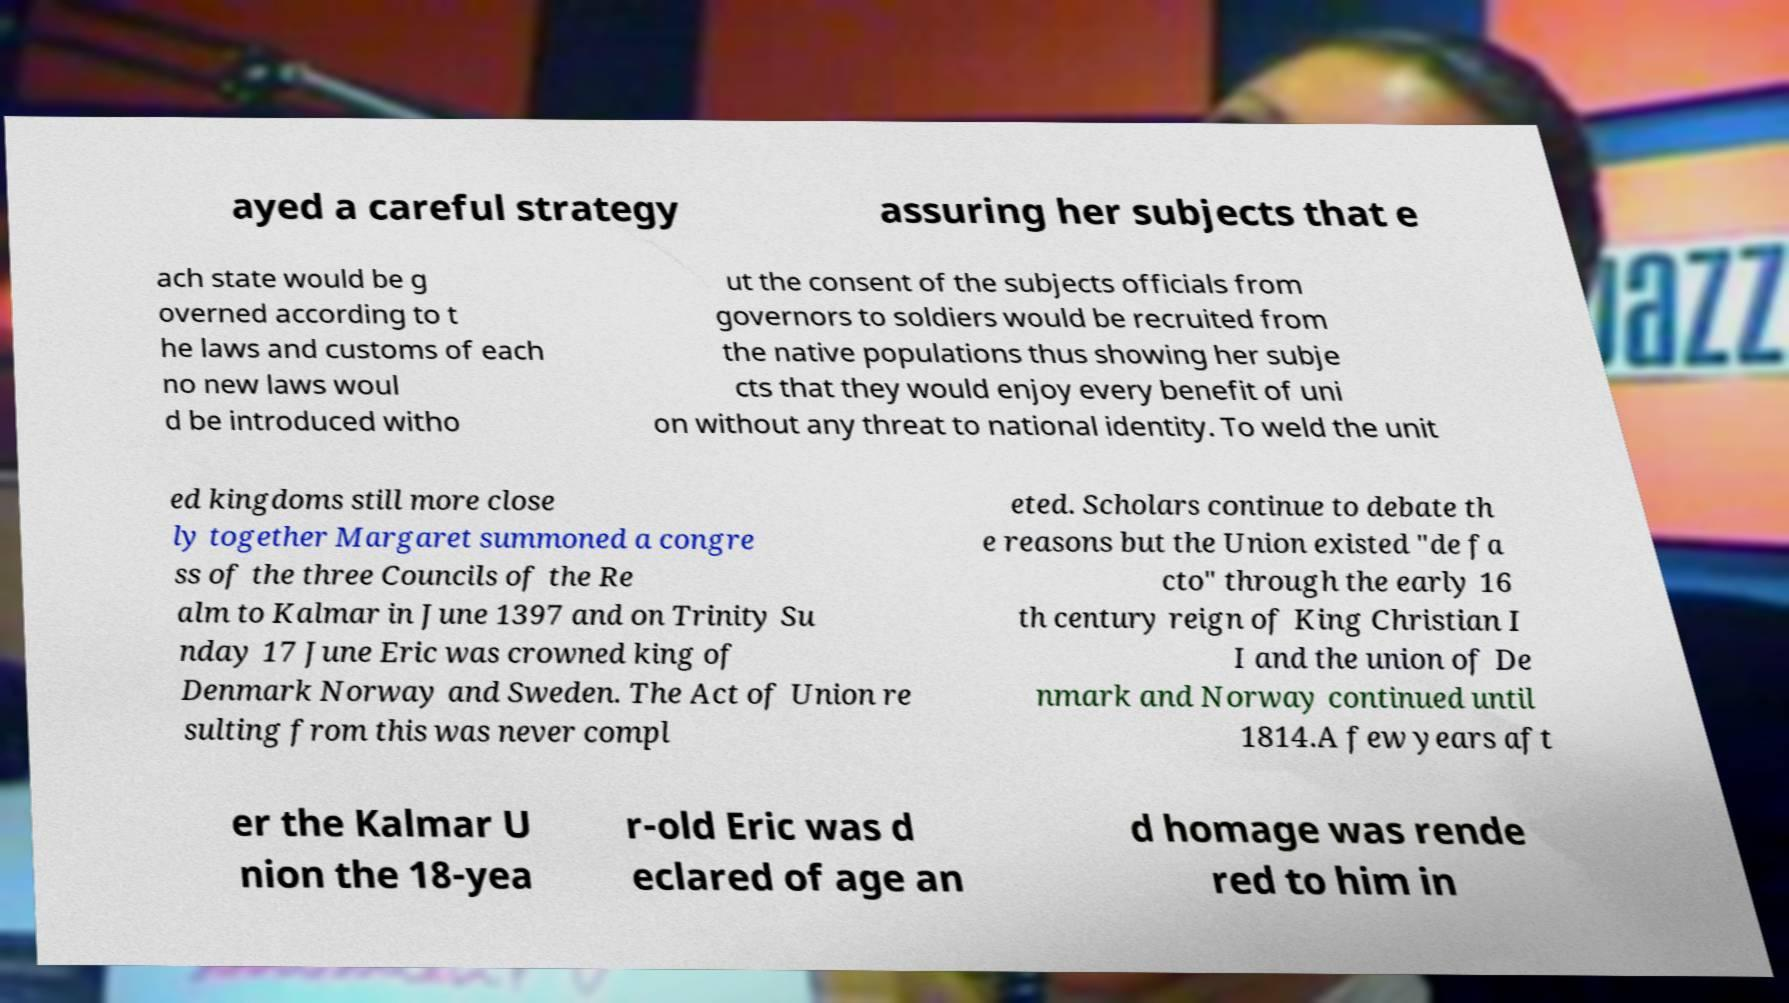Can you accurately transcribe the text from the provided image for me? ayed a careful strategy assuring her subjects that e ach state would be g overned according to t he laws and customs of each no new laws woul d be introduced witho ut the consent of the subjects officials from governors to soldiers would be recruited from the native populations thus showing her subje cts that they would enjoy every benefit of uni on without any threat to national identity. To weld the unit ed kingdoms still more close ly together Margaret summoned a congre ss of the three Councils of the Re alm to Kalmar in June 1397 and on Trinity Su nday 17 June Eric was crowned king of Denmark Norway and Sweden. The Act of Union re sulting from this was never compl eted. Scholars continue to debate th e reasons but the Union existed "de fa cto" through the early 16 th century reign of King Christian I I and the union of De nmark and Norway continued until 1814.A few years aft er the Kalmar U nion the 18-yea r-old Eric was d eclared of age an d homage was rende red to him in 